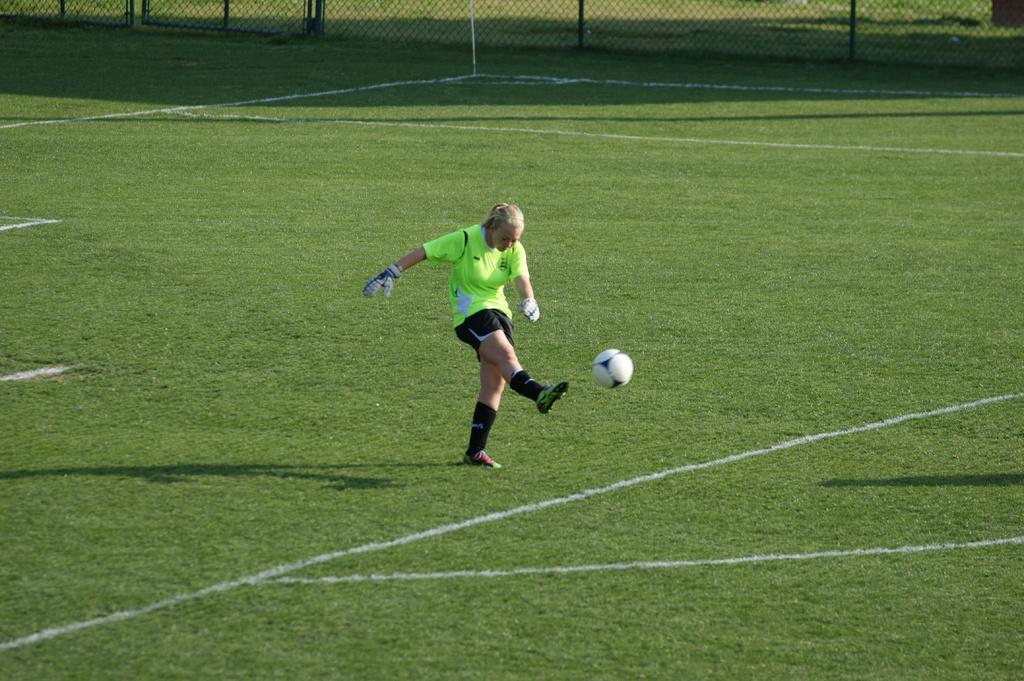What is the main subject of the image? There is a woman football player in the image. What action is the woman football player performing? The woman football player is kicking a ball. Where is the woman football player located? The woman football player is standing in a field. What type of song is the woman football player singing in the image? There is no indication in the image that the woman football player is singing a song, so it cannot be determined from the picture. 